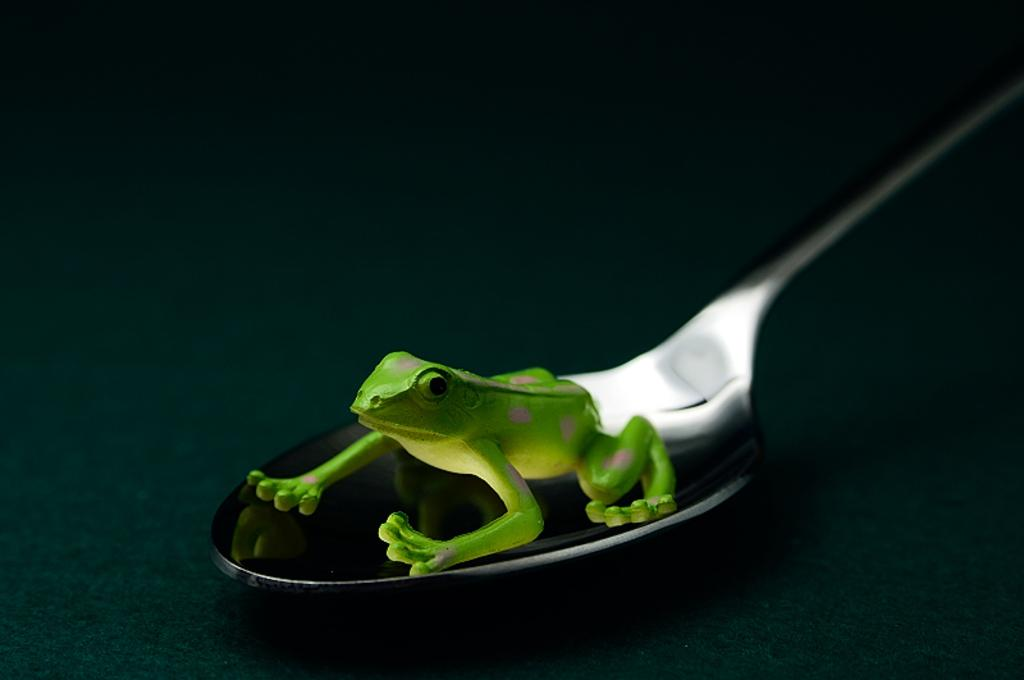What is the toy on the spoon in the image? There is a toy frog on a spoon in the image. What is the spoon resting on? The spoon is on an object in the image. How would you describe the lighting in the image? The background of the image is dark. What type of hat is the toy frog wearing in the image? There is no hat present on the toy frog in the image. Is there any indication of a fight happening in the image? There is no indication of a fight in the image; it only features a toy frog on a spoon. 